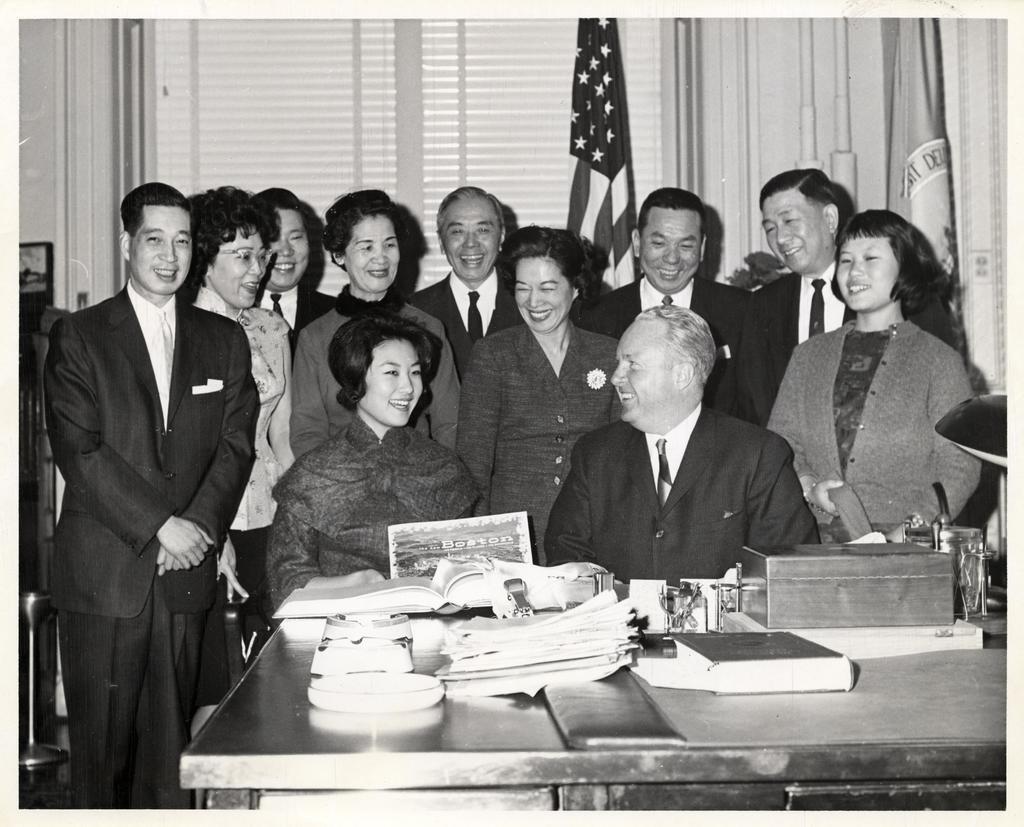In one or two sentences, can you explain what this image depicts? In this picture we can see a group of people, they are smiling, in front of them we can see a table, on this table we can see a box, books and some objects. In the background we can see flags, windows, curtains. 